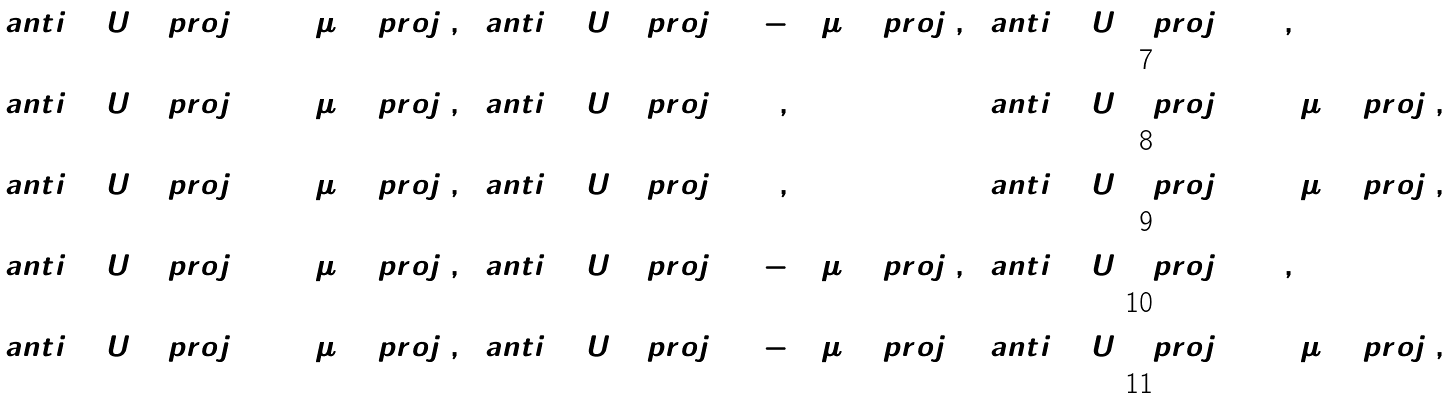<formula> <loc_0><loc_0><loc_500><loc_500>\ a n t i { \Gamma ^ { 1 2 } } { U _ { ( 2 ) } } \ p r o j _ { 1 } & = 2 4 \mu \Gamma ^ { 3 } \ p r o j _ { 1 } , & \ a n t i { \Gamma ^ { 5 6 } } { U _ { ( 6 ) } } \ p r o j _ { 1 } & = - 2 4 \mu \Gamma ^ { 3 } \ p r o j _ { 1 } , & \ a n t i { \Gamma ^ { 4 7 } } { U _ { ( 7 ) } } \ p r o j _ { 1 } & = 0 , \\ \ a n t i { \Gamma ^ { 1 2 } } { U _ { ( 2 ) } } \ p r o j _ { 2 } & = 2 4 \mu \Gamma ^ { 3 } \ p r o j _ { 2 } , & \ a n t i { \Gamma ^ { 5 6 } } { U _ { ( 6 ) } } \ p r o j _ { 2 } & = 0 , & \ a n t i { \Gamma ^ { 4 7 } } { U _ { ( 7 ) } } \ p r o j _ { 2 } & = 2 4 \mu \Gamma ^ { 3 } \ p r o j _ { 2 } , \\ \ a n t i { \Gamma ^ { 1 2 } } { U _ { ( 2 ) } } \ p r o j _ { 3 } & = 2 4 \mu \Gamma ^ { 3 } \ p r o j _ { 3 } , & \ a n t i { \Gamma ^ { 5 6 } } { U _ { ( 6 ) } } \ p r o j _ { 3 } & = 0 , & \ a n t i { \Gamma ^ { 4 7 } } { U _ { ( 7 ) } } \ p r o j _ { 3 } & = 2 4 \mu \Gamma ^ { 3 } \ p r o j _ { 3 } , \\ \ a n t i { \Gamma ^ { 1 2 } } { U _ { ( 2 ) } } \ p r o j _ { 4 } & = 2 4 \mu \Gamma ^ { 3 } \ p r o j _ { 4 } , & \ a n t i { \Gamma ^ { 5 6 } } { U _ { ( 6 ) } } \ p r o j _ { 4 } & = - 2 4 \mu \Gamma ^ { 3 } \ p r o j _ { 4 } , & \ a n t i { \Gamma ^ { 4 7 } } { U _ { ( 7 ) } } \ p r o j _ { 4 } & = 0 , \\ \ a n t i { \Gamma ^ { 1 2 } } { U _ { ( 2 ) } } \ p r o j _ { 8 } & = 3 2 \mu \Gamma ^ { 3 } \ p r o j _ { 8 } , & \ a n t i { \Gamma ^ { 5 6 } } { U _ { ( 6 ) } } \ p r o j _ { 8 } & = - 1 6 \mu \Gamma ^ { 3 } \ p r o j _ { 8 } ; & \ a n t i { \Gamma ^ { 4 7 } } { U _ { ( 7 ) } } \ p r o j _ { 8 } & = 1 6 \mu \Gamma ^ { 3 } \ p r o j _ { 8 } ,</formula> 